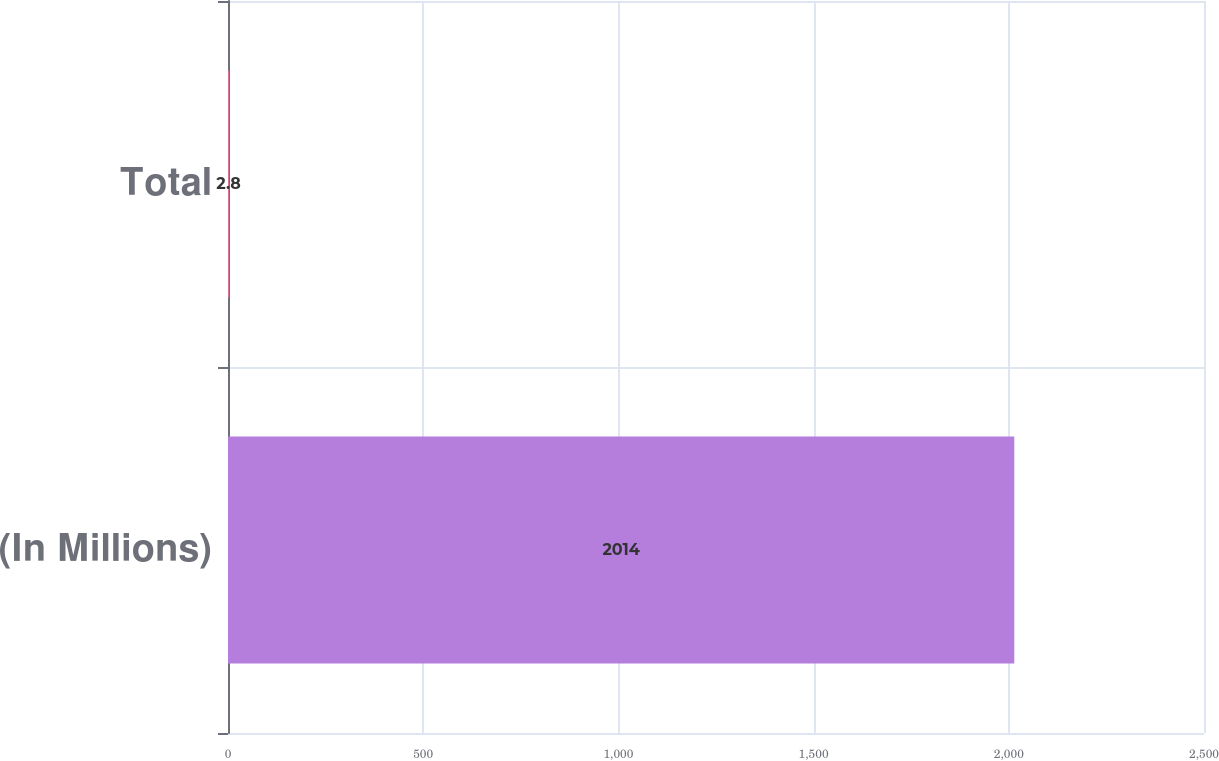Convert chart to OTSL. <chart><loc_0><loc_0><loc_500><loc_500><bar_chart><fcel>(In Millions)<fcel>Total<nl><fcel>2014<fcel>2.8<nl></chart> 